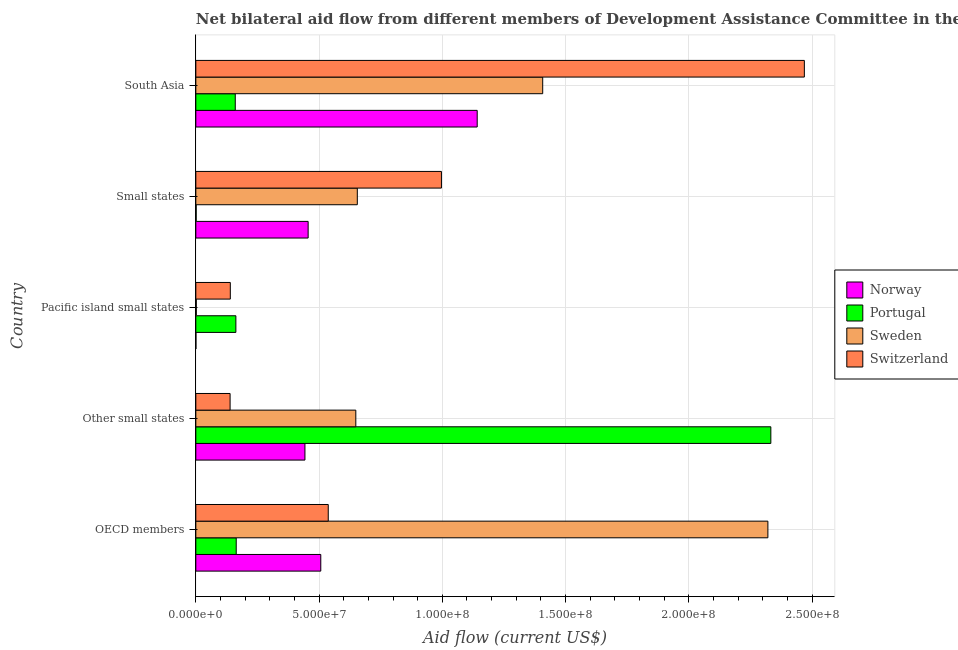How many different coloured bars are there?
Give a very brief answer. 4. How many groups of bars are there?
Make the answer very short. 5. Are the number of bars per tick equal to the number of legend labels?
Offer a very short reply. Yes. How many bars are there on the 4th tick from the top?
Your response must be concise. 4. What is the label of the 4th group of bars from the top?
Your response must be concise. Other small states. What is the amount of aid given by switzerland in South Asia?
Your answer should be very brief. 2.47e+08. Across all countries, what is the maximum amount of aid given by sweden?
Give a very brief answer. 2.32e+08. Across all countries, what is the minimum amount of aid given by switzerland?
Give a very brief answer. 1.39e+07. In which country was the amount of aid given by portugal maximum?
Offer a terse response. Other small states. In which country was the amount of aid given by norway minimum?
Your answer should be compact. Pacific island small states. What is the total amount of aid given by switzerland in the graph?
Keep it short and to the point. 4.28e+08. What is the difference between the amount of aid given by sweden in Other small states and that in Pacific island small states?
Offer a terse response. 6.47e+07. What is the difference between the amount of aid given by portugal in South Asia and the amount of aid given by switzerland in Pacific island small states?
Make the answer very short. 2.01e+06. What is the average amount of aid given by norway per country?
Your response must be concise. 5.09e+07. What is the difference between the amount of aid given by switzerland and amount of aid given by portugal in OECD members?
Your response must be concise. 3.73e+07. What is the ratio of the amount of aid given by norway in OECD members to that in Pacific island small states?
Offer a very short reply. 1267.5. Is the difference between the amount of aid given by norway in OECD members and South Asia greater than the difference between the amount of aid given by switzerland in OECD members and South Asia?
Make the answer very short. Yes. What is the difference between the highest and the second highest amount of aid given by sweden?
Provide a short and direct response. 9.14e+07. What is the difference between the highest and the lowest amount of aid given by portugal?
Provide a short and direct response. 2.33e+08. In how many countries, is the amount of aid given by sweden greater than the average amount of aid given by sweden taken over all countries?
Your answer should be compact. 2. Is it the case that in every country, the sum of the amount of aid given by switzerland and amount of aid given by portugal is greater than the sum of amount of aid given by sweden and amount of aid given by norway?
Your answer should be compact. No. Is it the case that in every country, the sum of the amount of aid given by norway and amount of aid given by portugal is greater than the amount of aid given by sweden?
Your answer should be compact. No. How many bars are there?
Provide a short and direct response. 20. How many countries are there in the graph?
Give a very brief answer. 5. Are the values on the major ticks of X-axis written in scientific E-notation?
Make the answer very short. Yes. Where does the legend appear in the graph?
Ensure brevity in your answer.  Center right. What is the title of the graph?
Give a very brief answer. Net bilateral aid flow from different members of Development Assistance Committee in the year 1992. What is the label or title of the X-axis?
Ensure brevity in your answer.  Aid flow (current US$). What is the Aid flow (current US$) in Norway in OECD members?
Keep it short and to the point. 5.07e+07. What is the Aid flow (current US$) of Portugal in OECD members?
Make the answer very short. 1.64e+07. What is the Aid flow (current US$) in Sweden in OECD members?
Keep it short and to the point. 2.32e+08. What is the Aid flow (current US$) of Switzerland in OECD members?
Provide a succinct answer. 5.37e+07. What is the Aid flow (current US$) in Norway in Other small states?
Provide a succinct answer. 4.43e+07. What is the Aid flow (current US$) of Portugal in Other small states?
Your answer should be very brief. 2.33e+08. What is the Aid flow (current US$) in Sweden in Other small states?
Your response must be concise. 6.49e+07. What is the Aid flow (current US$) in Switzerland in Other small states?
Offer a terse response. 1.39e+07. What is the Aid flow (current US$) of Norway in Pacific island small states?
Keep it short and to the point. 4.00e+04. What is the Aid flow (current US$) in Portugal in Pacific island small states?
Provide a succinct answer. 1.62e+07. What is the Aid flow (current US$) in Switzerland in Pacific island small states?
Provide a short and direct response. 1.40e+07. What is the Aid flow (current US$) of Norway in Small states?
Your answer should be very brief. 4.56e+07. What is the Aid flow (current US$) in Portugal in Small states?
Offer a very short reply. 1.40e+05. What is the Aid flow (current US$) in Sweden in Small states?
Your answer should be compact. 6.55e+07. What is the Aid flow (current US$) of Switzerland in Small states?
Your answer should be very brief. 9.96e+07. What is the Aid flow (current US$) in Norway in South Asia?
Your answer should be compact. 1.14e+08. What is the Aid flow (current US$) of Portugal in South Asia?
Keep it short and to the point. 1.60e+07. What is the Aid flow (current US$) in Sweden in South Asia?
Provide a short and direct response. 1.41e+08. What is the Aid flow (current US$) in Switzerland in South Asia?
Make the answer very short. 2.47e+08. Across all countries, what is the maximum Aid flow (current US$) in Norway?
Provide a short and direct response. 1.14e+08. Across all countries, what is the maximum Aid flow (current US$) in Portugal?
Ensure brevity in your answer.  2.33e+08. Across all countries, what is the maximum Aid flow (current US$) of Sweden?
Offer a very short reply. 2.32e+08. Across all countries, what is the maximum Aid flow (current US$) in Switzerland?
Provide a short and direct response. 2.47e+08. Across all countries, what is the minimum Aid flow (current US$) in Portugal?
Offer a terse response. 1.40e+05. Across all countries, what is the minimum Aid flow (current US$) in Switzerland?
Provide a short and direct response. 1.39e+07. What is the total Aid flow (current US$) in Norway in the graph?
Provide a short and direct response. 2.55e+08. What is the total Aid flow (current US$) in Portugal in the graph?
Give a very brief answer. 2.82e+08. What is the total Aid flow (current US$) of Sweden in the graph?
Provide a succinct answer. 5.03e+08. What is the total Aid flow (current US$) of Switzerland in the graph?
Provide a short and direct response. 4.28e+08. What is the difference between the Aid flow (current US$) in Norway in OECD members and that in Other small states?
Provide a succinct answer. 6.43e+06. What is the difference between the Aid flow (current US$) in Portugal in OECD members and that in Other small states?
Give a very brief answer. -2.17e+08. What is the difference between the Aid flow (current US$) of Sweden in OECD members and that in Other small states?
Keep it short and to the point. 1.67e+08. What is the difference between the Aid flow (current US$) in Switzerland in OECD members and that in Other small states?
Offer a terse response. 3.98e+07. What is the difference between the Aid flow (current US$) of Norway in OECD members and that in Pacific island small states?
Ensure brevity in your answer.  5.07e+07. What is the difference between the Aid flow (current US$) in Portugal in OECD members and that in Pacific island small states?
Make the answer very short. 1.40e+05. What is the difference between the Aid flow (current US$) in Sweden in OECD members and that in Pacific island small states?
Provide a succinct answer. 2.32e+08. What is the difference between the Aid flow (current US$) in Switzerland in OECD members and that in Pacific island small states?
Make the answer very short. 3.97e+07. What is the difference between the Aid flow (current US$) in Norway in OECD members and that in Small states?
Offer a terse response. 5.13e+06. What is the difference between the Aid flow (current US$) of Portugal in OECD members and that in Small states?
Provide a succinct answer. 1.62e+07. What is the difference between the Aid flow (current US$) in Sweden in OECD members and that in Small states?
Your response must be concise. 1.67e+08. What is the difference between the Aid flow (current US$) in Switzerland in OECD members and that in Small states?
Give a very brief answer. -4.59e+07. What is the difference between the Aid flow (current US$) of Norway in OECD members and that in South Asia?
Your response must be concise. -6.35e+07. What is the difference between the Aid flow (current US$) in Sweden in OECD members and that in South Asia?
Your response must be concise. 9.14e+07. What is the difference between the Aid flow (current US$) in Switzerland in OECD members and that in South Asia?
Your answer should be very brief. -1.93e+08. What is the difference between the Aid flow (current US$) in Norway in Other small states and that in Pacific island small states?
Your response must be concise. 4.42e+07. What is the difference between the Aid flow (current US$) of Portugal in Other small states and that in Pacific island small states?
Give a very brief answer. 2.17e+08. What is the difference between the Aid flow (current US$) in Sweden in Other small states and that in Pacific island small states?
Your answer should be very brief. 6.47e+07. What is the difference between the Aid flow (current US$) of Norway in Other small states and that in Small states?
Make the answer very short. -1.30e+06. What is the difference between the Aid flow (current US$) in Portugal in Other small states and that in Small states?
Provide a succinct answer. 2.33e+08. What is the difference between the Aid flow (current US$) in Sweden in Other small states and that in Small states?
Offer a very short reply. -6.10e+05. What is the difference between the Aid flow (current US$) of Switzerland in Other small states and that in Small states?
Your response must be concise. -8.58e+07. What is the difference between the Aid flow (current US$) of Norway in Other small states and that in South Asia?
Provide a short and direct response. -6.99e+07. What is the difference between the Aid flow (current US$) of Portugal in Other small states and that in South Asia?
Keep it short and to the point. 2.17e+08. What is the difference between the Aid flow (current US$) in Sweden in Other small states and that in South Asia?
Offer a terse response. -7.58e+07. What is the difference between the Aid flow (current US$) of Switzerland in Other small states and that in South Asia?
Provide a succinct answer. -2.33e+08. What is the difference between the Aid flow (current US$) in Norway in Pacific island small states and that in Small states?
Offer a terse response. -4.55e+07. What is the difference between the Aid flow (current US$) in Portugal in Pacific island small states and that in Small states?
Your answer should be compact. 1.61e+07. What is the difference between the Aid flow (current US$) in Sweden in Pacific island small states and that in Small states?
Offer a terse response. -6.53e+07. What is the difference between the Aid flow (current US$) in Switzerland in Pacific island small states and that in Small states?
Provide a short and direct response. -8.57e+07. What is the difference between the Aid flow (current US$) of Norway in Pacific island small states and that in South Asia?
Keep it short and to the point. -1.14e+08. What is the difference between the Aid flow (current US$) in Sweden in Pacific island small states and that in South Asia?
Offer a very short reply. -1.41e+08. What is the difference between the Aid flow (current US$) of Switzerland in Pacific island small states and that in South Asia?
Offer a very short reply. -2.33e+08. What is the difference between the Aid flow (current US$) of Norway in Small states and that in South Asia?
Offer a very short reply. -6.86e+07. What is the difference between the Aid flow (current US$) in Portugal in Small states and that in South Asia?
Keep it short and to the point. -1.59e+07. What is the difference between the Aid flow (current US$) in Sweden in Small states and that in South Asia?
Offer a terse response. -7.52e+07. What is the difference between the Aid flow (current US$) in Switzerland in Small states and that in South Asia?
Make the answer very short. -1.47e+08. What is the difference between the Aid flow (current US$) of Norway in OECD members and the Aid flow (current US$) of Portugal in Other small states?
Provide a succinct answer. -1.83e+08. What is the difference between the Aid flow (current US$) in Norway in OECD members and the Aid flow (current US$) in Sweden in Other small states?
Your answer should be very brief. -1.42e+07. What is the difference between the Aid flow (current US$) of Norway in OECD members and the Aid flow (current US$) of Switzerland in Other small states?
Offer a very short reply. 3.68e+07. What is the difference between the Aid flow (current US$) of Portugal in OECD members and the Aid flow (current US$) of Sweden in Other small states?
Provide a short and direct response. -4.85e+07. What is the difference between the Aid flow (current US$) of Portugal in OECD members and the Aid flow (current US$) of Switzerland in Other small states?
Provide a succinct answer. 2.49e+06. What is the difference between the Aid flow (current US$) of Sweden in OECD members and the Aid flow (current US$) of Switzerland in Other small states?
Offer a very short reply. 2.18e+08. What is the difference between the Aid flow (current US$) of Norway in OECD members and the Aid flow (current US$) of Portugal in Pacific island small states?
Your answer should be very brief. 3.44e+07. What is the difference between the Aid flow (current US$) in Norway in OECD members and the Aid flow (current US$) in Sweden in Pacific island small states?
Make the answer very short. 5.05e+07. What is the difference between the Aid flow (current US$) of Norway in OECD members and the Aid flow (current US$) of Switzerland in Pacific island small states?
Make the answer very short. 3.67e+07. What is the difference between the Aid flow (current US$) of Portugal in OECD members and the Aid flow (current US$) of Sweden in Pacific island small states?
Your answer should be very brief. 1.62e+07. What is the difference between the Aid flow (current US$) of Portugal in OECD members and the Aid flow (current US$) of Switzerland in Pacific island small states?
Make the answer very short. 2.40e+06. What is the difference between the Aid flow (current US$) of Sweden in OECD members and the Aid flow (current US$) of Switzerland in Pacific island small states?
Offer a terse response. 2.18e+08. What is the difference between the Aid flow (current US$) in Norway in OECD members and the Aid flow (current US$) in Portugal in Small states?
Your answer should be compact. 5.06e+07. What is the difference between the Aid flow (current US$) in Norway in OECD members and the Aid flow (current US$) in Sweden in Small states?
Give a very brief answer. -1.48e+07. What is the difference between the Aid flow (current US$) in Norway in OECD members and the Aid flow (current US$) in Switzerland in Small states?
Provide a short and direct response. -4.90e+07. What is the difference between the Aid flow (current US$) in Portugal in OECD members and the Aid flow (current US$) in Sweden in Small states?
Give a very brief answer. -4.91e+07. What is the difference between the Aid flow (current US$) in Portugal in OECD members and the Aid flow (current US$) in Switzerland in Small states?
Give a very brief answer. -8.33e+07. What is the difference between the Aid flow (current US$) of Sweden in OECD members and the Aid flow (current US$) of Switzerland in Small states?
Ensure brevity in your answer.  1.32e+08. What is the difference between the Aid flow (current US$) of Norway in OECD members and the Aid flow (current US$) of Portugal in South Asia?
Ensure brevity in your answer.  3.47e+07. What is the difference between the Aid flow (current US$) in Norway in OECD members and the Aid flow (current US$) in Sweden in South Asia?
Make the answer very short. -9.00e+07. What is the difference between the Aid flow (current US$) of Norway in OECD members and the Aid flow (current US$) of Switzerland in South Asia?
Ensure brevity in your answer.  -1.96e+08. What is the difference between the Aid flow (current US$) of Portugal in OECD members and the Aid flow (current US$) of Sweden in South Asia?
Your response must be concise. -1.24e+08. What is the difference between the Aid flow (current US$) in Portugal in OECD members and the Aid flow (current US$) in Switzerland in South Asia?
Provide a short and direct response. -2.31e+08. What is the difference between the Aid flow (current US$) of Sweden in OECD members and the Aid flow (current US$) of Switzerland in South Asia?
Make the answer very short. -1.48e+07. What is the difference between the Aid flow (current US$) in Norway in Other small states and the Aid flow (current US$) in Portugal in Pacific island small states?
Give a very brief answer. 2.80e+07. What is the difference between the Aid flow (current US$) in Norway in Other small states and the Aid flow (current US$) in Sweden in Pacific island small states?
Your answer should be very brief. 4.41e+07. What is the difference between the Aid flow (current US$) of Norway in Other small states and the Aid flow (current US$) of Switzerland in Pacific island small states?
Give a very brief answer. 3.03e+07. What is the difference between the Aid flow (current US$) of Portugal in Other small states and the Aid flow (current US$) of Sweden in Pacific island small states?
Your answer should be very brief. 2.33e+08. What is the difference between the Aid flow (current US$) in Portugal in Other small states and the Aid flow (current US$) in Switzerland in Pacific island small states?
Make the answer very short. 2.19e+08. What is the difference between the Aid flow (current US$) of Sweden in Other small states and the Aid flow (current US$) of Switzerland in Pacific island small states?
Keep it short and to the point. 5.09e+07. What is the difference between the Aid flow (current US$) of Norway in Other small states and the Aid flow (current US$) of Portugal in Small states?
Make the answer very short. 4.41e+07. What is the difference between the Aid flow (current US$) in Norway in Other small states and the Aid flow (current US$) in Sweden in Small states?
Keep it short and to the point. -2.12e+07. What is the difference between the Aid flow (current US$) in Norway in Other small states and the Aid flow (current US$) in Switzerland in Small states?
Your answer should be compact. -5.54e+07. What is the difference between the Aid flow (current US$) of Portugal in Other small states and the Aid flow (current US$) of Sweden in Small states?
Your response must be concise. 1.68e+08. What is the difference between the Aid flow (current US$) in Portugal in Other small states and the Aid flow (current US$) in Switzerland in Small states?
Your response must be concise. 1.34e+08. What is the difference between the Aid flow (current US$) of Sweden in Other small states and the Aid flow (current US$) of Switzerland in Small states?
Provide a succinct answer. -3.47e+07. What is the difference between the Aid flow (current US$) in Norway in Other small states and the Aid flow (current US$) in Portugal in South Asia?
Your answer should be very brief. 2.83e+07. What is the difference between the Aid flow (current US$) of Norway in Other small states and the Aid flow (current US$) of Sweden in South Asia?
Give a very brief answer. -9.65e+07. What is the difference between the Aid flow (current US$) in Norway in Other small states and the Aid flow (current US$) in Switzerland in South Asia?
Ensure brevity in your answer.  -2.03e+08. What is the difference between the Aid flow (current US$) of Portugal in Other small states and the Aid flow (current US$) of Sweden in South Asia?
Ensure brevity in your answer.  9.26e+07. What is the difference between the Aid flow (current US$) of Portugal in Other small states and the Aid flow (current US$) of Switzerland in South Asia?
Make the answer very short. -1.36e+07. What is the difference between the Aid flow (current US$) in Sweden in Other small states and the Aid flow (current US$) in Switzerland in South Asia?
Ensure brevity in your answer.  -1.82e+08. What is the difference between the Aid flow (current US$) of Norway in Pacific island small states and the Aid flow (current US$) of Portugal in Small states?
Your response must be concise. -1.00e+05. What is the difference between the Aid flow (current US$) in Norway in Pacific island small states and the Aid flow (current US$) in Sweden in Small states?
Offer a very short reply. -6.55e+07. What is the difference between the Aid flow (current US$) in Norway in Pacific island small states and the Aid flow (current US$) in Switzerland in Small states?
Your response must be concise. -9.96e+07. What is the difference between the Aid flow (current US$) of Portugal in Pacific island small states and the Aid flow (current US$) of Sweden in Small states?
Keep it short and to the point. -4.93e+07. What is the difference between the Aid flow (current US$) of Portugal in Pacific island small states and the Aid flow (current US$) of Switzerland in Small states?
Your answer should be very brief. -8.34e+07. What is the difference between the Aid flow (current US$) of Sweden in Pacific island small states and the Aid flow (current US$) of Switzerland in Small states?
Your answer should be very brief. -9.95e+07. What is the difference between the Aid flow (current US$) in Norway in Pacific island small states and the Aid flow (current US$) in Portugal in South Asia?
Ensure brevity in your answer.  -1.60e+07. What is the difference between the Aid flow (current US$) of Norway in Pacific island small states and the Aid flow (current US$) of Sweden in South Asia?
Your response must be concise. -1.41e+08. What is the difference between the Aid flow (current US$) of Norway in Pacific island small states and the Aid flow (current US$) of Switzerland in South Asia?
Provide a short and direct response. -2.47e+08. What is the difference between the Aid flow (current US$) of Portugal in Pacific island small states and the Aid flow (current US$) of Sweden in South Asia?
Provide a succinct answer. -1.24e+08. What is the difference between the Aid flow (current US$) in Portugal in Pacific island small states and the Aid flow (current US$) in Switzerland in South Asia?
Keep it short and to the point. -2.31e+08. What is the difference between the Aid flow (current US$) of Sweden in Pacific island small states and the Aid flow (current US$) of Switzerland in South Asia?
Provide a succinct answer. -2.47e+08. What is the difference between the Aid flow (current US$) of Norway in Small states and the Aid flow (current US$) of Portugal in South Asia?
Your answer should be very brief. 2.96e+07. What is the difference between the Aid flow (current US$) in Norway in Small states and the Aid flow (current US$) in Sweden in South Asia?
Make the answer very short. -9.52e+07. What is the difference between the Aid flow (current US$) of Norway in Small states and the Aid flow (current US$) of Switzerland in South Asia?
Ensure brevity in your answer.  -2.01e+08. What is the difference between the Aid flow (current US$) in Portugal in Small states and the Aid flow (current US$) in Sweden in South Asia?
Keep it short and to the point. -1.41e+08. What is the difference between the Aid flow (current US$) in Portugal in Small states and the Aid flow (current US$) in Switzerland in South Asia?
Your answer should be compact. -2.47e+08. What is the difference between the Aid flow (current US$) of Sweden in Small states and the Aid flow (current US$) of Switzerland in South Asia?
Provide a short and direct response. -1.81e+08. What is the average Aid flow (current US$) of Norway per country?
Your response must be concise. 5.09e+07. What is the average Aid flow (current US$) of Portugal per country?
Offer a very short reply. 5.64e+07. What is the average Aid flow (current US$) in Sweden per country?
Give a very brief answer. 1.01e+08. What is the average Aid flow (current US$) in Switzerland per country?
Your answer should be very brief. 8.56e+07. What is the difference between the Aid flow (current US$) in Norway and Aid flow (current US$) in Portugal in OECD members?
Your answer should be compact. 3.43e+07. What is the difference between the Aid flow (current US$) of Norway and Aid flow (current US$) of Sweden in OECD members?
Your answer should be very brief. -1.81e+08. What is the difference between the Aid flow (current US$) in Norway and Aid flow (current US$) in Switzerland in OECD members?
Provide a succinct answer. -3.03e+06. What is the difference between the Aid flow (current US$) in Portugal and Aid flow (current US$) in Sweden in OECD members?
Ensure brevity in your answer.  -2.16e+08. What is the difference between the Aid flow (current US$) in Portugal and Aid flow (current US$) in Switzerland in OECD members?
Make the answer very short. -3.73e+07. What is the difference between the Aid flow (current US$) in Sweden and Aid flow (current US$) in Switzerland in OECD members?
Offer a terse response. 1.78e+08. What is the difference between the Aid flow (current US$) in Norway and Aid flow (current US$) in Portugal in Other small states?
Offer a very short reply. -1.89e+08. What is the difference between the Aid flow (current US$) of Norway and Aid flow (current US$) of Sweden in Other small states?
Your answer should be very brief. -2.06e+07. What is the difference between the Aid flow (current US$) in Norway and Aid flow (current US$) in Switzerland in Other small states?
Keep it short and to the point. 3.04e+07. What is the difference between the Aid flow (current US$) in Portugal and Aid flow (current US$) in Sweden in Other small states?
Offer a terse response. 1.68e+08. What is the difference between the Aid flow (current US$) of Portugal and Aid flow (current US$) of Switzerland in Other small states?
Offer a terse response. 2.19e+08. What is the difference between the Aid flow (current US$) in Sweden and Aid flow (current US$) in Switzerland in Other small states?
Offer a terse response. 5.10e+07. What is the difference between the Aid flow (current US$) of Norway and Aid flow (current US$) of Portugal in Pacific island small states?
Your answer should be very brief. -1.62e+07. What is the difference between the Aid flow (current US$) in Norway and Aid flow (current US$) in Sweden in Pacific island small states?
Ensure brevity in your answer.  -1.50e+05. What is the difference between the Aid flow (current US$) in Norway and Aid flow (current US$) in Switzerland in Pacific island small states?
Your answer should be compact. -1.40e+07. What is the difference between the Aid flow (current US$) in Portugal and Aid flow (current US$) in Sweden in Pacific island small states?
Keep it short and to the point. 1.61e+07. What is the difference between the Aid flow (current US$) in Portugal and Aid flow (current US$) in Switzerland in Pacific island small states?
Provide a short and direct response. 2.26e+06. What is the difference between the Aid flow (current US$) of Sweden and Aid flow (current US$) of Switzerland in Pacific island small states?
Provide a short and direct response. -1.38e+07. What is the difference between the Aid flow (current US$) in Norway and Aid flow (current US$) in Portugal in Small states?
Ensure brevity in your answer.  4.54e+07. What is the difference between the Aid flow (current US$) of Norway and Aid flow (current US$) of Sweden in Small states?
Your answer should be very brief. -2.00e+07. What is the difference between the Aid flow (current US$) in Norway and Aid flow (current US$) in Switzerland in Small states?
Provide a succinct answer. -5.41e+07. What is the difference between the Aid flow (current US$) of Portugal and Aid flow (current US$) of Sweden in Small states?
Your answer should be compact. -6.54e+07. What is the difference between the Aid flow (current US$) in Portugal and Aid flow (current US$) in Switzerland in Small states?
Your answer should be very brief. -9.95e+07. What is the difference between the Aid flow (current US$) of Sweden and Aid flow (current US$) of Switzerland in Small states?
Keep it short and to the point. -3.41e+07. What is the difference between the Aid flow (current US$) in Norway and Aid flow (current US$) in Portugal in South Asia?
Make the answer very short. 9.82e+07. What is the difference between the Aid flow (current US$) in Norway and Aid flow (current US$) in Sweden in South Asia?
Your answer should be compact. -2.66e+07. What is the difference between the Aid flow (current US$) in Norway and Aid flow (current US$) in Switzerland in South Asia?
Keep it short and to the point. -1.33e+08. What is the difference between the Aid flow (current US$) of Portugal and Aid flow (current US$) of Sweden in South Asia?
Your response must be concise. -1.25e+08. What is the difference between the Aid flow (current US$) of Portugal and Aid flow (current US$) of Switzerland in South Asia?
Your answer should be compact. -2.31e+08. What is the difference between the Aid flow (current US$) of Sweden and Aid flow (current US$) of Switzerland in South Asia?
Your answer should be compact. -1.06e+08. What is the ratio of the Aid flow (current US$) in Norway in OECD members to that in Other small states?
Offer a terse response. 1.15. What is the ratio of the Aid flow (current US$) in Portugal in OECD members to that in Other small states?
Make the answer very short. 0.07. What is the ratio of the Aid flow (current US$) of Sweden in OECD members to that in Other small states?
Your answer should be very brief. 3.58. What is the ratio of the Aid flow (current US$) in Switzerland in OECD members to that in Other small states?
Provide a succinct answer. 3.87. What is the ratio of the Aid flow (current US$) in Norway in OECD members to that in Pacific island small states?
Ensure brevity in your answer.  1267.5. What is the ratio of the Aid flow (current US$) in Portugal in OECD members to that in Pacific island small states?
Ensure brevity in your answer.  1.01. What is the ratio of the Aid flow (current US$) in Sweden in OECD members to that in Pacific island small states?
Offer a very short reply. 1221.58. What is the ratio of the Aid flow (current US$) of Switzerland in OECD members to that in Pacific island small states?
Ensure brevity in your answer.  3.84. What is the ratio of the Aid flow (current US$) in Norway in OECD members to that in Small states?
Make the answer very short. 1.11. What is the ratio of the Aid flow (current US$) in Portugal in OECD members to that in Small states?
Provide a short and direct response. 117.07. What is the ratio of the Aid flow (current US$) of Sweden in OECD members to that in Small states?
Your answer should be compact. 3.54. What is the ratio of the Aid flow (current US$) of Switzerland in OECD members to that in Small states?
Keep it short and to the point. 0.54. What is the ratio of the Aid flow (current US$) in Norway in OECD members to that in South Asia?
Your answer should be compact. 0.44. What is the ratio of the Aid flow (current US$) of Portugal in OECD members to that in South Asia?
Offer a terse response. 1.02. What is the ratio of the Aid flow (current US$) in Sweden in OECD members to that in South Asia?
Make the answer very short. 1.65. What is the ratio of the Aid flow (current US$) in Switzerland in OECD members to that in South Asia?
Offer a very short reply. 0.22. What is the ratio of the Aid flow (current US$) in Norway in Other small states to that in Pacific island small states?
Keep it short and to the point. 1106.75. What is the ratio of the Aid flow (current US$) of Portugal in Other small states to that in Pacific island small states?
Provide a short and direct response. 14.36. What is the ratio of the Aid flow (current US$) of Sweden in Other small states to that in Pacific island small states?
Your answer should be very brief. 341.63. What is the ratio of the Aid flow (current US$) of Switzerland in Other small states to that in Pacific island small states?
Offer a terse response. 0.99. What is the ratio of the Aid flow (current US$) of Norway in Other small states to that in Small states?
Give a very brief answer. 0.97. What is the ratio of the Aid flow (current US$) in Portugal in Other small states to that in Small states?
Offer a terse response. 1666.43. What is the ratio of the Aid flow (current US$) of Switzerland in Other small states to that in Small states?
Give a very brief answer. 0.14. What is the ratio of the Aid flow (current US$) of Norway in Other small states to that in South Asia?
Your response must be concise. 0.39. What is the ratio of the Aid flow (current US$) in Portugal in Other small states to that in South Asia?
Your answer should be very brief. 14.58. What is the ratio of the Aid flow (current US$) in Sweden in Other small states to that in South Asia?
Your answer should be very brief. 0.46. What is the ratio of the Aid flow (current US$) of Switzerland in Other small states to that in South Asia?
Provide a succinct answer. 0.06. What is the ratio of the Aid flow (current US$) of Norway in Pacific island small states to that in Small states?
Provide a succinct answer. 0. What is the ratio of the Aid flow (current US$) of Portugal in Pacific island small states to that in Small states?
Your response must be concise. 116.07. What is the ratio of the Aid flow (current US$) of Sweden in Pacific island small states to that in Small states?
Offer a terse response. 0. What is the ratio of the Aid flow (current US$) of Switzerland in Pacific island small states to that in Small states?
Ensure brevity in your answer.  0.14. What is the ratio of the Aid flow (current US$) in Portugal in Pacific island small states to that in South Asia?
Offer a terse response. 1.02. What is the ratio of the Aid flow (current US$) in Sweden in Pacific island small states to that in South Asia?
Provide a succinct answer. 0. What is the ratio of the Aid flow (current US$) of Switzerland in Pacific island small states to that in South Asia?
Provide a short and direct response. 0.06. What is the ratio of the Aid flow (current US$) of Norway in Small states to that in South Asia?
Your response must be concise. 0.4. What is the ratio of the Aid flow (current US$) in Portugal in Small states to that in South Asia?
Give a very brief answer. 0.01. What is the ratio of the Aid flow (current US$) of Sweden in Small states to that in South Asia?
Ensure brevity in your answer.  0.47. What is the ratio of the Aid flow (current US$) in Switzerland in Small states to that in South Asia?
Give a very brief answer. 0.4. What is the difference between the highest and the second highest Aid flow (current US$) in Norway?
Offer a terse response. 6.35e+07. What is the difference between the highest and the second highest Aid flow (current US$) in Portugal?
Your answer should be very brief. 2.17e+08. What is the difference between the highest and the second highest Aid flow (current US$) of Sweden?
Keep it short and to the point. 9.14e+07. What is the difference between the highest and the second highest Aid flow (current US$) in Switzerland?
Your answer should be very brief. 1.47e+08. What is the difference between the highest and the lowest Aid flow (current US$) in Norway?
Keep it short and to the point. 1.14e+08. What is the difference between the highest and the lowest Aid flow (current US$) of Portugal?
Ensure brevity in your answer.  2.33e+08. What is the difference between the highest and the lowest Aid flow (current US$) of Sweden?
Provide a short and direct response. 2.32e+08. What is the difference between the highest and the lowest Aid flow (current US$) in Switzerland?
Give a very brief answer. 2.33e+08. 